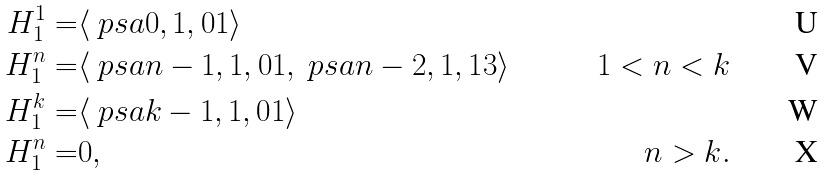Convert formula to latex. <formula><loc_0><loc_0><loc_500><loc_500>H ^ { 1 } _ { 1 } = & \langle \ p s a { 0 , 1 , 0 } 1 \rangle \\ H ^ { n } _ { 1 } = & \langle \ p s a { n - 1 , 1 , 0 } 1 , \ p s a { n - 2 , 1 , 1 } 3 \rangle & 1 < n < k \\ H ^ { k } _ { 1 } = & \langle \ p s a { k - 1 , 1 , 0 } 1 \rangle \\ H ^ { n } _ { 1 } = & 0 , & n > k .</formula> 